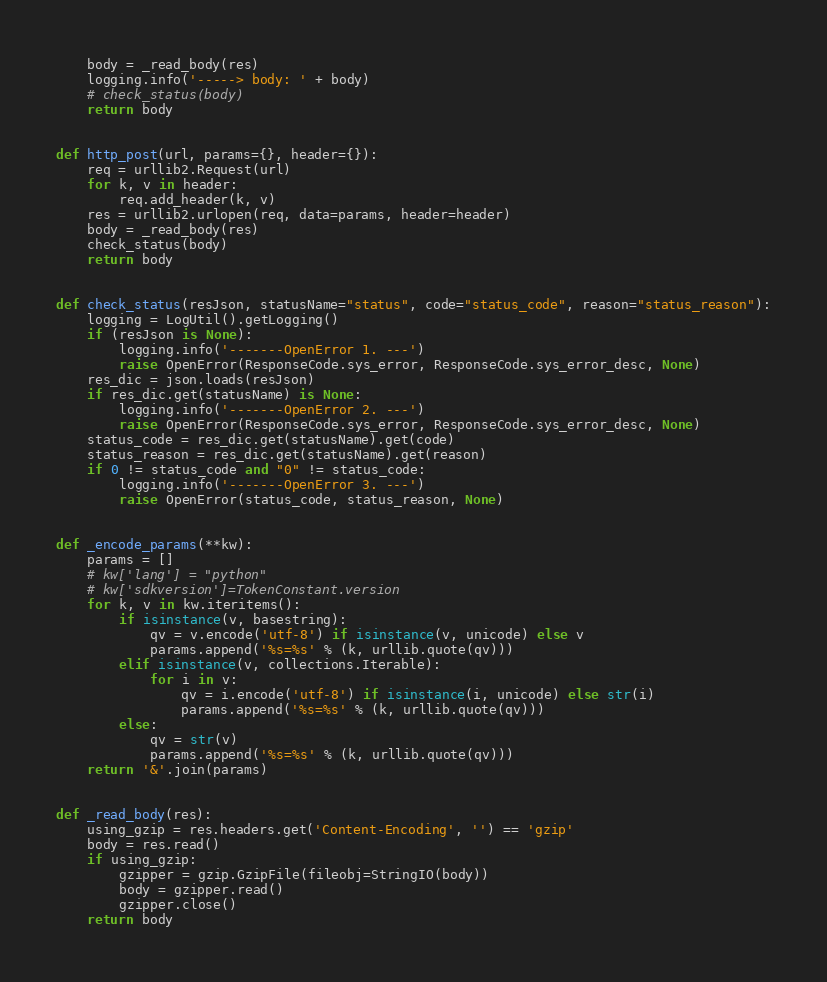<code> <loc_0><loc_0><loc_500><loc_500><_Python_>    body = _read_body(res)
    logging.info('-----> body: ' + body)
    # check_status(body)
    return body


def http_post(url, params={}, header={}):
    req = urllib2.Request(url)
    for k, v in header:
        req.add_header(k, v)
    res = urllib2.urlopen(req, data=params, header=header)
    body = _read_body(res)
    check_status(body)
    return body


def check_status(resJson, statusName="status", code="status_code", reason="status_reason"):
    logging = LogUtil().getLogging()
    if (resJson is None):
        logging.info('-------OpenError 1. ---')
        raise OpenError(ResponseCode.sys_error, ResponseCode.sys_error_desc, None)
    res_dic = json.loads(resJson)
    if res_dic.get(statusName) is None:
        logging.info('-------OpenError 2. ---')
        raise OpenError(ResponseCode.sys_error, ResponseCode.sys_error_desc, None)
    status_code = res_dic.get(statusName).get(code)
    status_reason = res_dic.get(statusName).get(reason)
    if 0 != status_code and "0" != status_code:
        logging.info('-------OpenError 3. ---')
        raise OpenError(status_code, status_reason, None)


def _encode_params(**kw):
    params = []
    # kw['lang'] = "python"
    # kw['sdkversion']=TokenConstant.version
    for k, v in kw.iteritems():
        if isinstance(v, basestring):
            qv = v.encode('utf-8') if isinstance(v, unicode) else v
            params.append('%s=%s' % (k, urllib.quote(qv)))
        elif isinstance(v, collections.Iterable):
            for i in v:
                qv = i.encode('utf-8') if isinstance(i, unicode) else str(i)
                params.append('%s=%s' % (k, urllib.quote(qv)))
        else:
            qv = str(v)
            params.append('%s=%s' % (k, urllib.quote(qv)))
    return '&'.join(params)


def _read_body(res):
    using_gzip = res.headers.get('Content-Encoding', '') == 'gzip'
    body = res.read()
    if using_gzip:
        gzipper = gzip.GzipFile(fileobj=StringIO(body))
        body = gzipper.read()
        gzipper.close()
    return body
</code> 